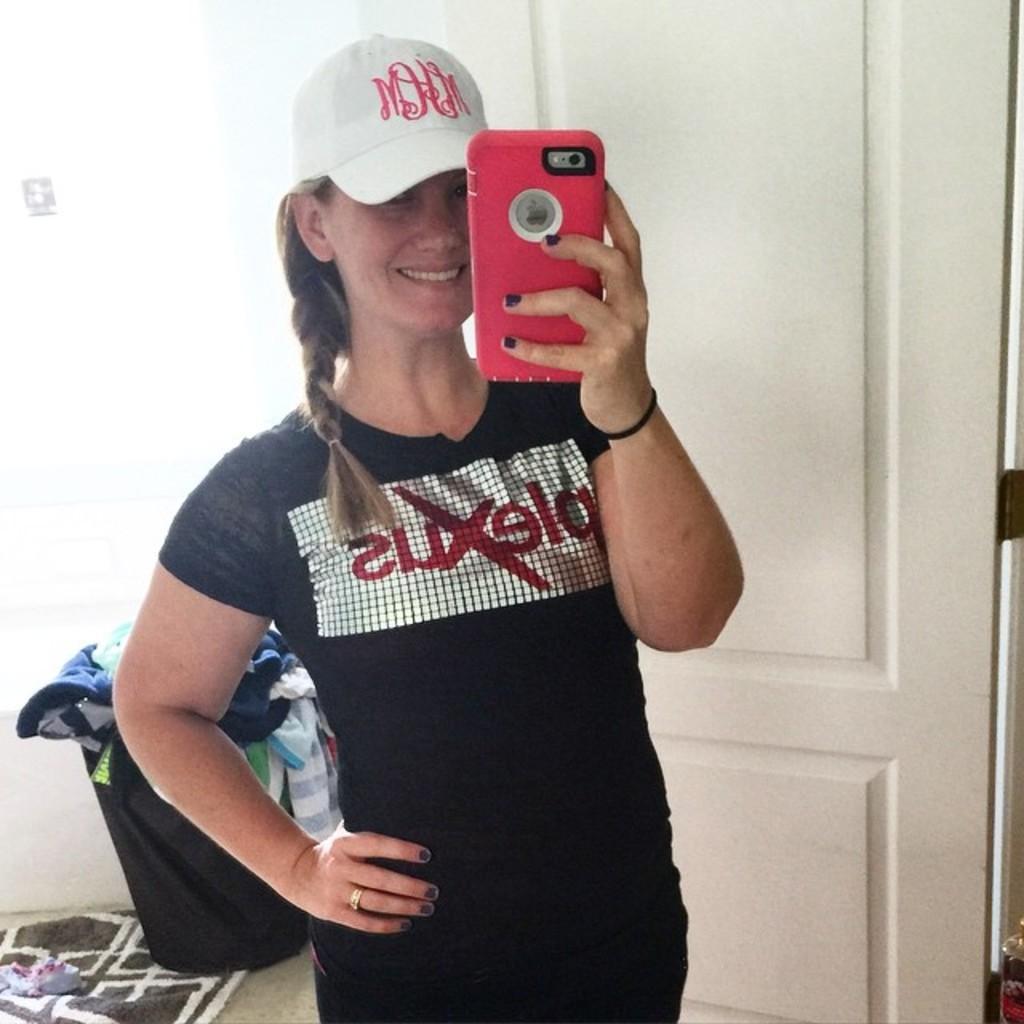How would you summarize this image in a sentence or two? A lady wearing a black dress and cap is holding a mobile. In the background there is a door, laundry bin, and some dresses inside the laundry bin and a carpet. 